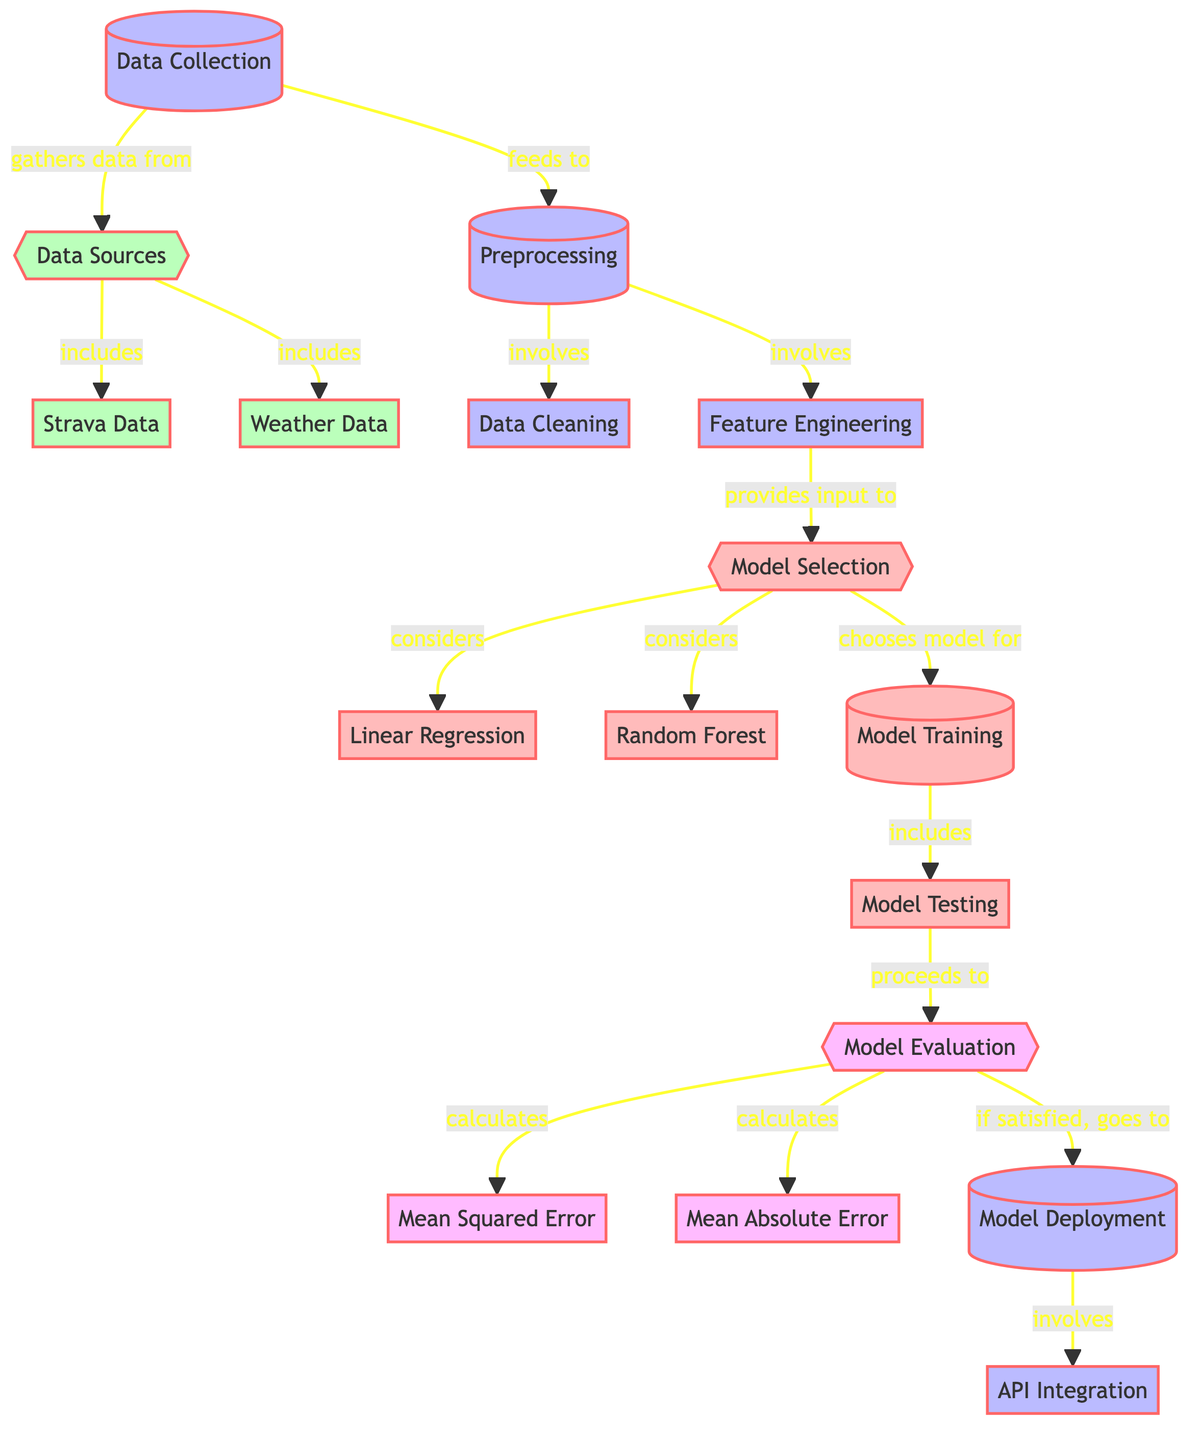What are the two main types of data sources? The diagram identifies "Strava Data" and "Weather Data" as the two main types of data sources under the "Data Sources" node.
Answer: Strava Data and Weather Data How many models are considered in the model selection phase? The diagram specifies that two models, "Linear Regression" and "Random Forest," are considered in the model selection phase.
Answer: Two What processes are involved in the preprocessing step? The diagram shows that "Cleaning" and "Feature Engineering" are the two processes directly involved in the preprocessing step.
Answer: Cleaning and Feature Engineering What is the final step after model evaluation if the results are satisfactory? The diagram indicates that if the evaluation is satisfactory, the process proceeds to "Model Deployment."
Answer: Model Deployment What metrics are calculated during the evaluation phase? The diagram lists "Mean Squared Error" and "Mean Absolute Error" as the metrics calculated during the evaluation.
Answer: Mean Squared Error and Mean Absolute Error Which model is preferred during training, linear regression or random forest? The diagram indicates that the model selection phase considers both models, but it does not explicitly state which one is preferred; this decision occurs during "Training."
Answer: Not specified in the diagram What integration is involved in the deployment step? The diagram points to "API Integration" as the specific integration involved in the deployment step.
Answer: API Integration Which phase follows model training? Testing immediately follows the training phase according to the diagram's flow.
Answer: Testing How is data fed from data collection to preprocessing? The diagram clearly shows an arrow indicating that data flows from "Data Collection" to "Preprocessing," demonstrating the directional relationship.
Answer: By feeding data What is the purpose of feature engineering in the diagram? Feature Engineering provides input to the model selection phase, thus playing a critical role in preparing data for model choice.
Answer: Provides input to model selection 